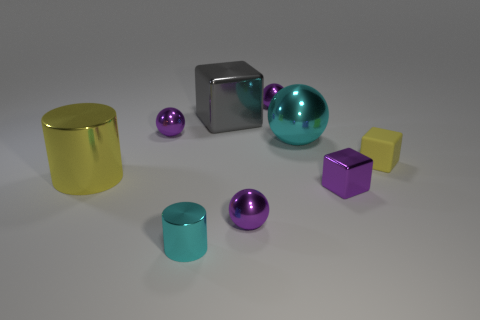How big is the cyan shiny thing that is behind the metallic block right of the cyan metallic object right of the big gray metal block?
Your answer should be very brief. Large. Is the number of large blocks behind the big gray cube less than the number of big cyan metallic balls that are in front of the tiny shiny cube?
Make the answer very short. No. What number of yellow blocks are made of the same material as the small cyan thing?
Make the answer very short. 0. There is a metallic sphere in front of the yellow object on the right side of the large cyan thing; is there a gray shiny block on the left side of it?
Your answer should be very brief. Yes. What is the shape of the small cyan object that is the same material as the big gray cube?
Provide a short and direct response. Cylinder. Is the number of large red cubes greater than the number of tiny purple shiny objects?
Offer a terse response. No. There is a tiny yellow matte object; is its shape the same as the big thing that is on the right side of the large metallic block?
Your answer should be compact. No. What material is the large ball?
Make the answer very short. Metal. What color is the tiny metallic thing to the right of the cyan sphere that is behind the shiny object that is right of the cyan sphere?
Give a very brief answer. Purple. What is the material of the other object that is the same shape as the yellow metal object?
Give a very brief answer. Metal. 